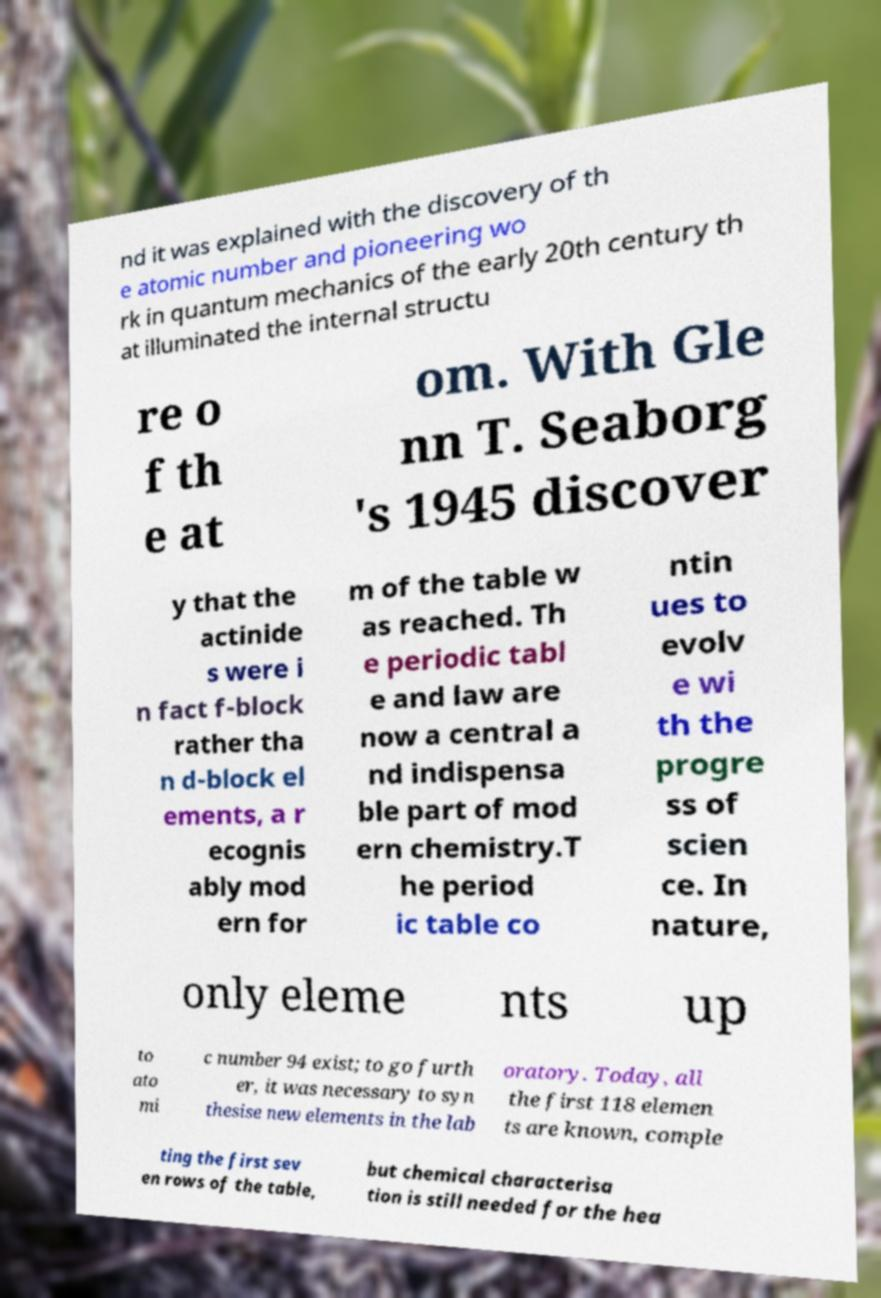Please identify and transcribe the text found in this image. nd it was explained with the discovery of th e atomic number and pioneering wo rk in quantum mechanics of the early 20th century th at illuminated the internal structu re o f th e at om. With Gle nn T. Seaborg 's 1945 discover y that the actinide s were i n fact f-block rather tha n d-block el ements, a r ecognis ably mod ern for m of the table w as reached. Th e periodic tabl e and law are now a central a nd indispensa ble part of mod ern chemistry.T he period ic table co ntin ues to evolv e wi th the progre ss of scien ce. In nature, only eleme nts up to ato mi c number 94 exist; to go furth er, it was necessary to syn thesise new elements in the lab oratory. Today, all the first 118 elemen ts are known, comple ting the first sev en rows of the table, but chemical characterisa tion is still needed for the hea 